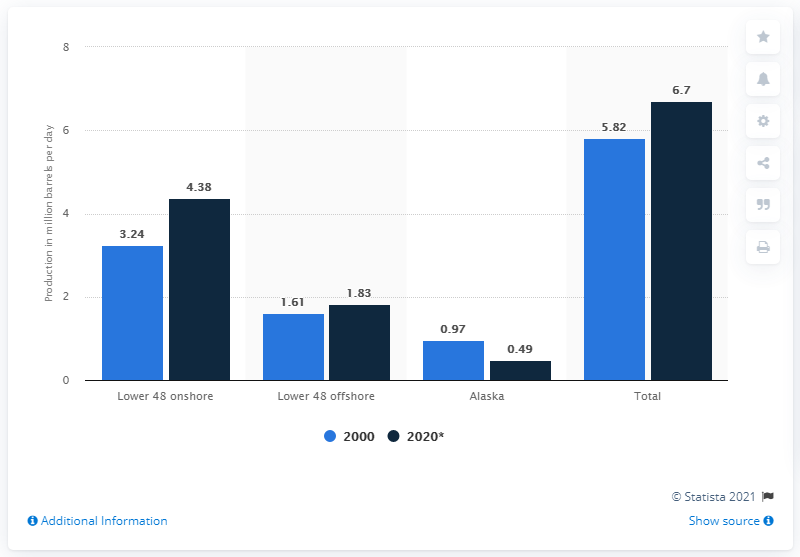Highlight a few significant elements in this photo. Alaska is projected to produce 0.49 barrels of crude oil in 2020, In 2000, approximately 0.97 barrels of crude oil were produced in the state of Alaska. 